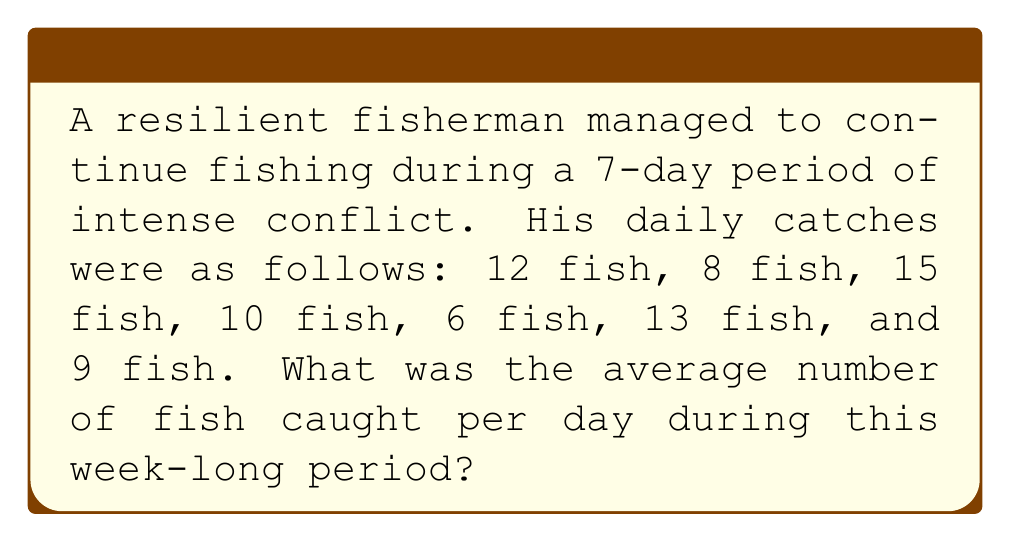Give your solution to this math problem. To find the average number of fish caught per day, we need to:

1. Calculate the total number of fish caught over the 7-day period
2. Divide this total by the number of days

Step 1: Calculate the total number of fish caught
$$\text{Total fish} = 12 + 8 + 15 + 10 + 6 + 13 + 9 = 73\text{ fish}$$

Step 2: Divide the total by the number of days
$$\text{Average} = \frac{\text{Total fish}}{\text{Number of days}} = \frac{73}{7}$$

To simplify this fraction:
$$\frac{73}{7} = 10\frac{3}{7} \approx 10.43\text{ fish per day}$$

Since we're dealing with whole fish, we round to the nearest whole number:
$$10.43 \approx 10\text{ fish per day}$$
Answer: The average number of fish caught per day was 10 fish. 